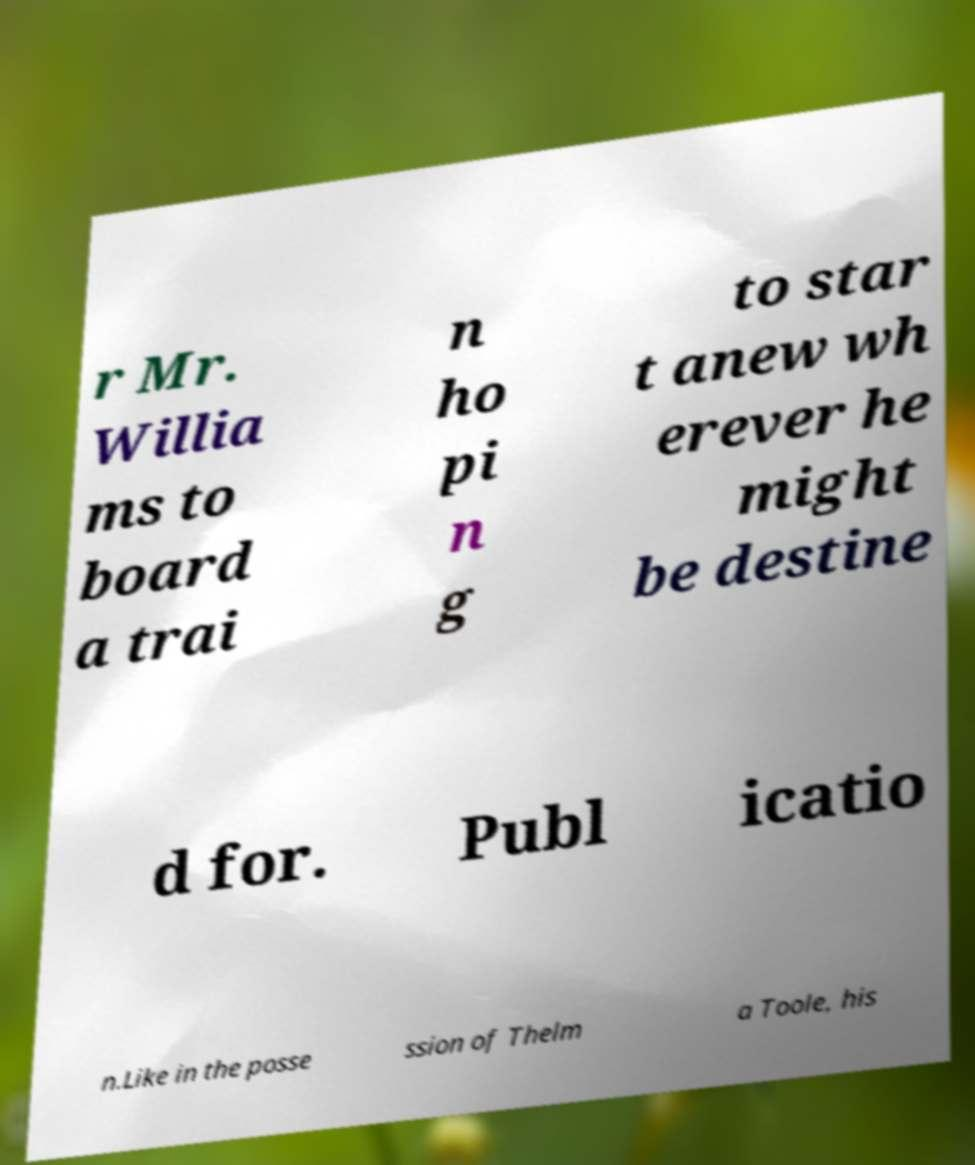Can you accurately transcribe the text from the provided image for me? r Mr. Willia ms to board a trai n ho pi n g to star t anew wh erever he might be destine d for. Publ icatio n.Like in the posse ssion of Thelm a Toole, his 